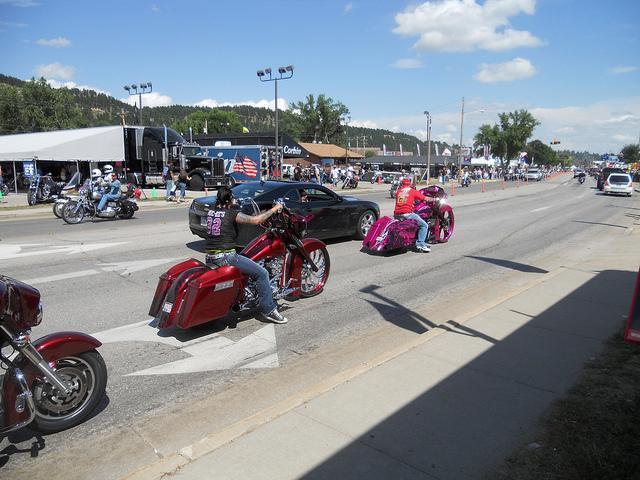How many trucks can be seen?
Give a very brief answer. 2. How many motorcycles are in the photo?
Give a very brief answer. 3. How many people can you see?
Give a very brief answer. 2. How many zebras have their faces showing in the image?
Give a very brief answer. 0. 